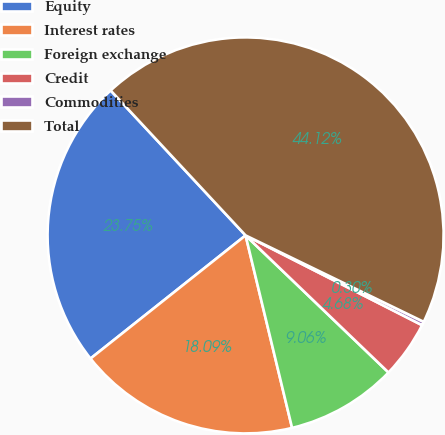<chart> <loc_0><loc_0><loc_500><loc_500><pie_chart><fcel>Equity<fcel>Interest rates<fcel>Foreign exchange<fcel>Credit<fcel>Commodities<fcel>Total<nl><fcel>23.75%<fcel>18.09%<fcel>9.06%<fcel>4.68%<fcel>0.3%<fcel>44.12%<nl></chart> 